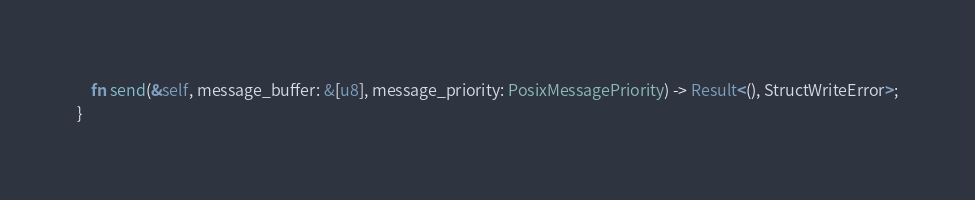<code> <loc_0><loc_0><loc_500><loc_500><_Rust_>	fn send(&self, message_buffer: &[u8], message_priority: PosixMessagePriority) -> Result<(), StructWriteError>;
}
</code> 